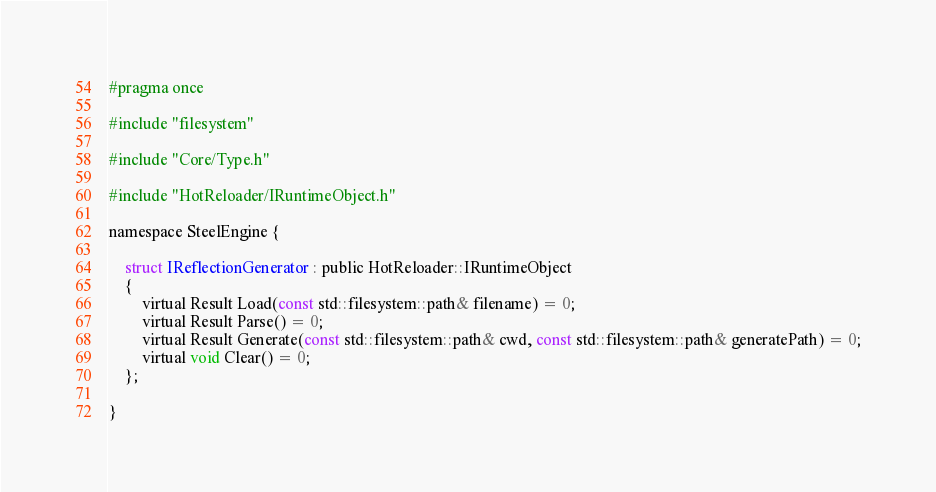Convert code to text. <code><loc_0><loc_0><loc_500><loc_500><_C_>#pragma once

#include "filesystem"

#include "Core/Type.h"

#include "HotReloader/IRuntimeObject.h"

namespace SteelEngine {

    struct IReflectionGenerator : public HotReloader::IRuntimeObject
    {
        virtual Result Load(const std::filesystem::path& filename) = 0;
        virtual Result Parse() = 0;
        virtual Result Generate(const std::filesystem::path& cwd, const std::filesystem::path& generatePath) = 0;
        virtual void Clear() = 0;
    };

}</code> 